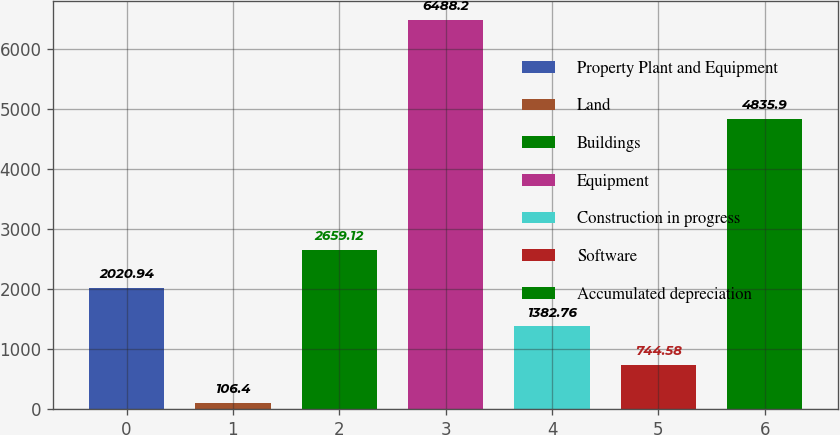Convert chart. <chart><loc_0><loc_0><loc_500><loc_500><bar_chart><fcel>Property Plant and Equipment<fcel>Land<fcel>Buildings<fcel>Equipment<fcel>Construction in progress<fcel>Software<fcel>Accumulated depreciation<nl><fcel>2020.94<fcel>106.4<fcel>2659.12<fcel>6488.2<fcel>1382.76<fcel>744.58<fcel>4835.9<nl></chart> 